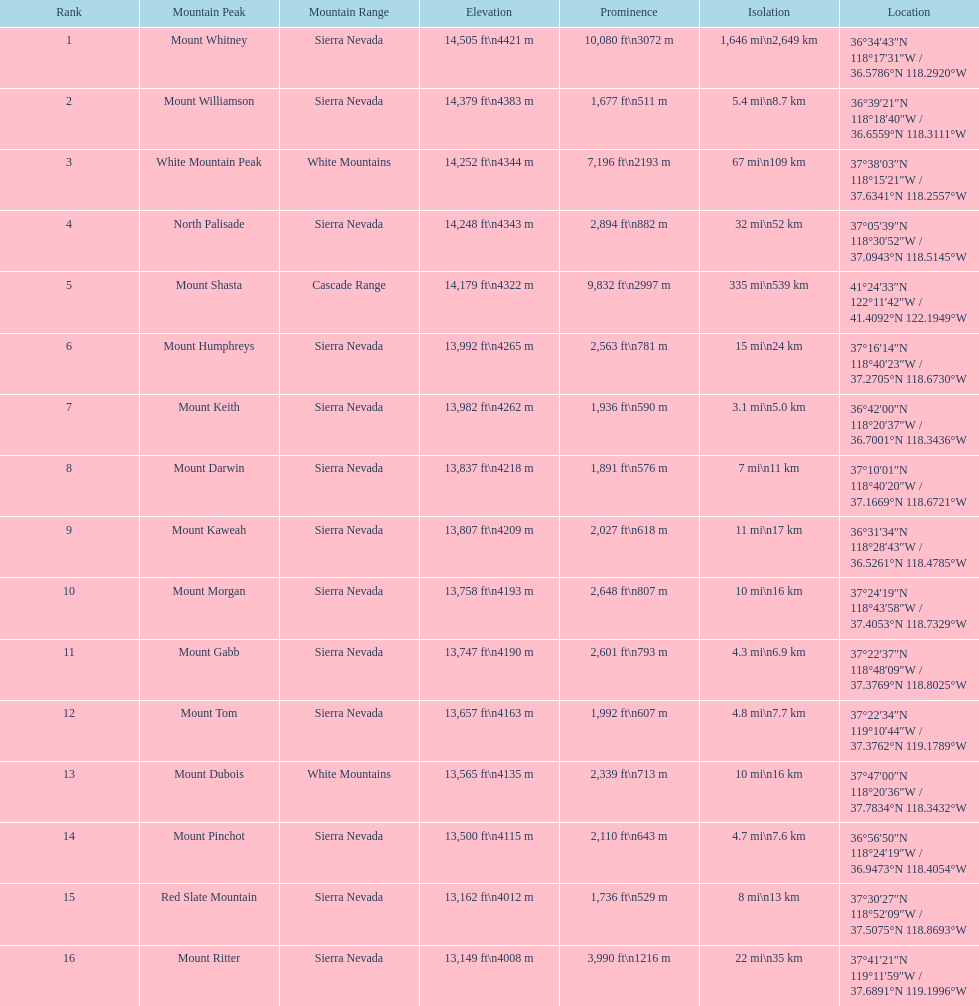What are all the mountain tops? Mount Whitney, Mount Williamson, White Mountain Peak, North Palisade, Mount Shasta, Mount Humphreys, Mount Keith, Mount Darwin, Mount Kaweah, Mount Morgan, Mount Gabb, Mount Tom, Mount Dubois, Mount Pinchot, Red Slate Mountain, Mount Ritter. Where are they situated? Sierra Nevada, Sierra Nevada, White Mountains, Sierra Nevada, Cascade Range, Sierra Nevada, Sierra Nevada, Sierra Nevada, Sierra Nevada, Sierra Nevada, Sierra Nevada, Sierra Nevada, White Mountains, Sierra Nevada, Sierra Nevada, Sierra Nevada. How elevated are they? 14,505 ft\n4421 m, 14,379 ft\n4383 m, 14,252 ft\n4344 m, 14,248 ft\n4343 m, 14,179 ft\n4322 m, 13,992 ft\n4265 m, 13,982 ft\n4262 m, 13,837 ft\n4218 m, 13,807 ft\n4209 m, 13,758 ft\n4193 m, 13,747 ft\n4190 m, 13,657 ft\n4163 m, 13,565 ft\n4135 m, 13,500 ft\n4115 m, 13,162 ft\n4012 m, 13,149 ft\n4008 m. What about specifically the peaks in the sierra nevadas? 14,505 ft\n4421 m, 14,379 ft\n4383 m, 14,248 ft\n4343 m, 13,992 ft\n4265 m, 13,982 ft\n4262 m, 13,837 ft\n4218 m, 13,807 ft\n4209 m, 13,758 ft\n4193 m, 13,747 ft\n4190 m, 13,657 ft\n4163 m, 13,500 ft\n4115 m, 13,162 ft\n4012 m, 13,149 ft\n4008 m. And of those, which is the loftiest? Mount Whitney. 